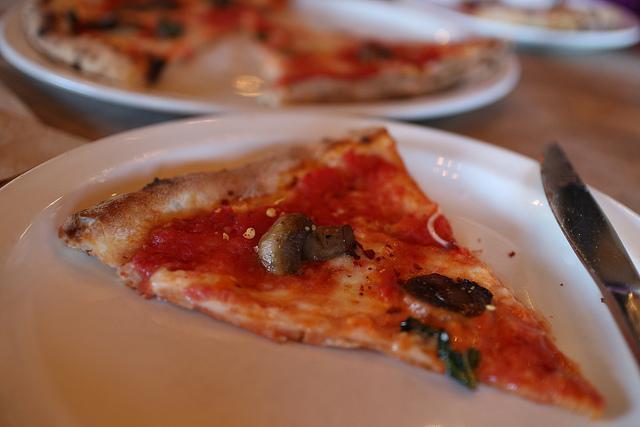How many utensils do you see?
Give a very brief answer. 1. How many plates are there?
Give a very brief answer. 3. How many pizzas are in the photo?
Give a very brief answer. 3. 